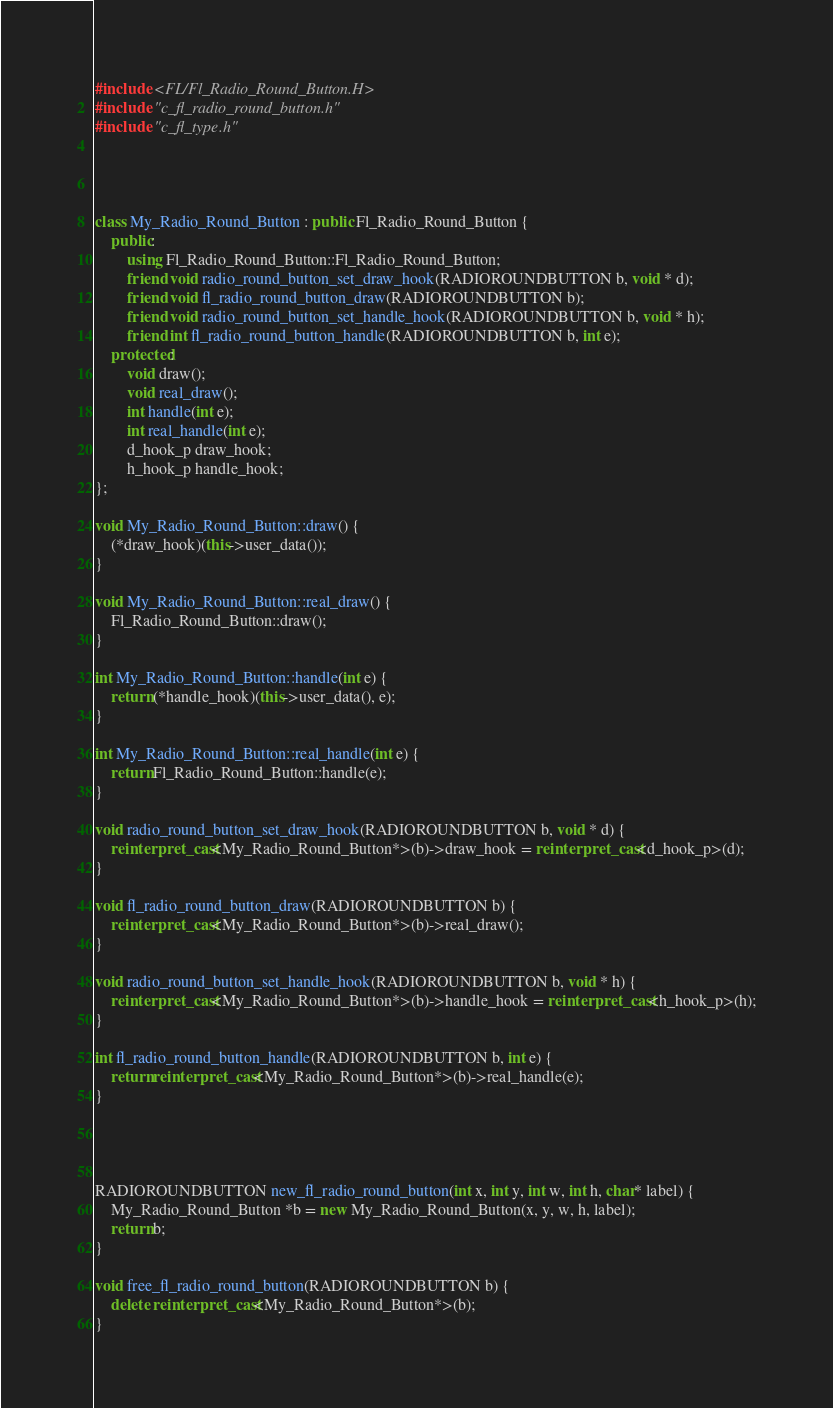Convert code to text. <code><loc_0><loc_0><loc_500><loc_500><_C++_>

#include <FL/Fl_Radio_Round_Button.H>
#include "c_fl_radio_round_button.h"
#include "c_fl_type.h"




class My_Radio_Round_Button : public Fl_Radio_Round_Button {
    public:
        using Fl_Radio_Round_Button::Fl_Radio_Round_Button;
        friend void radio_round_button_set_draw_hook(RADIOROUNDBUTTON b, void * d);
        friend void fl_radio_round_button_draw(RADIOROUNDBUTTON b);
        friend void radio_round_button_set_handle_hook(RADIOROUNDBUTTON b, void * h);
        friend int fl_radio_round_button_handle(RADIOROUNDBUTTON b, int e);
    protected:
        void draw();
        void real_draw();
        int handle(int e);
        int real_handle(int e);
        d_hook_p draw_hook;
        h_hook_p handle_hook;
};

void My_Radio_Round_Button::draw() {
    (*draw_hook)(this->user_data());
}

void My_Radio_Round_Button::real_draw() {
    Fl_Radio_Round_Button::draw();
}

int My_Radio_Round_Button::handle(int e) {
    return (*handle_hook)(this->user_data(), e);
}

int My_Radio_Round_Button::real_handle(int e) {
    return Fl_Radio_Round_Button::handle(e);
}

void radio_round_button_set_draw_hook(RADIOROUNDBUTTON b, void * d) {
    reinterpret_cast<My_Radio_Round_Button*>(b)->draw_hook = reinterpret_cast<d_hook_p>(d);
}

void fl_radio_round_button_draw(RADIOROUNDBUTTON b) {
    reinterpret_cast<My_Radio_Round_Button*>(b)->real_draw();
}

void radio_round_button_set_handle_hook(RADIOROUNDBUTTON b, void * h) {
    reinterpret_cast<My_Radio_Round_Button*>(b)->handle_hook = reinterpret_cast<h_hook_p>(h);
}

int fl_radio_round_button_handle(RADIOROUNDBUTTON b, int e) {
    return reinterpret_cast<My_Radio_Round_Button*>(b)->real_handle(e);
}




RADIOROUNDBUTTON new_fl_radio_round_button(int x, int y, int w, int h, char* label) {
    My_Radio_Round_Button *b = new My_Radio_Round_Button(x, y, w, h, label);
    return b;
}

void free_fl_radio_round_button(RADIOROUNDBUTTON b) {
    delete reinterpret_cast<My_Radio_Round_Button*>(b);
}

</code> 